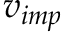Convert formula to latex. <formula><loc_0><loc_0><loc_500><loc_500>v _ { i m p }</formula> 